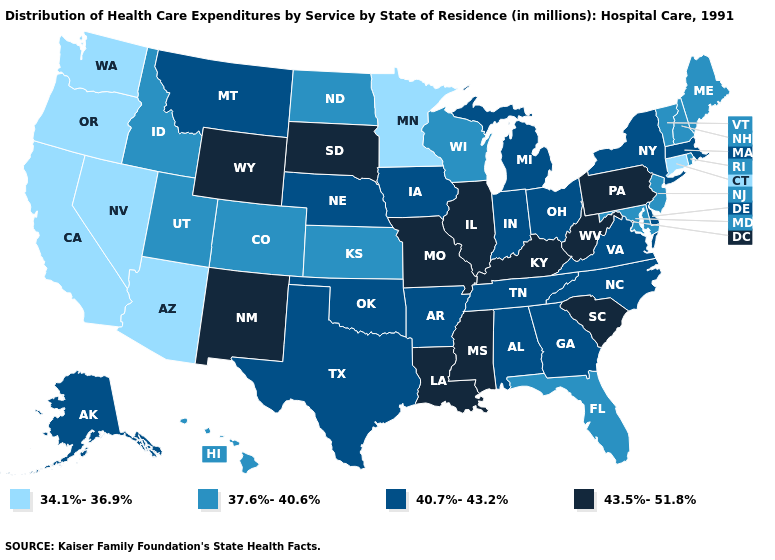What is the value of Connecticut?
Answer briefly. 34.1%-36.9%. Among the states that border New Jersey , does Pennsylvania have the highest value?
Write a very short answer. Yes. What is the value of Maryland?
Short answer required. 37.6%-40.6%. Which states hav the highest value in the South?
Short answer required. Kentucky, Louisiana, Mississippi, South Carolina, West Virginia. What is the lowest value in states that border Georgia?
Write a very short answer. 37.6%-40.6%. What is the value of Massachusetts?
Concise answer only. 40.7%-43.2%. Among the states that border Kentucky , does Illinois have the highest value?
Quick response, please. Yes. Which states have the highest value in the USA?
Answer briefly. Illinois, Kentucky, Louisiana, Mississippi, Missouri, New Mexico, Pennsylvania, South Carolina, South Dakota, West Virginia, Wyoming. Does South Dakota have the same value as Pennsylvania?
Quick response, please. Yes. Name the states that have a value in the range 34.1%-36.9%?
Concise answer only. Arizona, California, Connecticut, Minnesota, Nevada, Oregon, Washington. What is the lowest value in the MidWest?
Write a very short answer. 34.1%-36.9%. Name the states that have a value in the range 37.6%-40.6%?
Answer briefly. Colorado, Florida, Hawaii, Idaho, Kansas, Maine, Maryland, New Hampshire, New Jersey, North Dakota, Rhode Island, Utah, Vermont, Wisconsin. Among the states that border Rhode Island , does Massachusetts have the highest value?
Give a very brief answer. Yes. What is the highest value in states that border Florida?
Short answer required. 40.7%-43.2%. Does Oklahoma have the highest value in the USA?
Short answer required. No. 